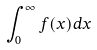Convert formula to latex. <formula><loc_0><loc_0><loc_500><loc_500>\int _ { 0 } ^ { \infty } f ( x ) d x</formula> 